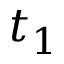<formula> <loc_0><loc_0><loc_500><loc_500>t _ { 1 }</formula> 